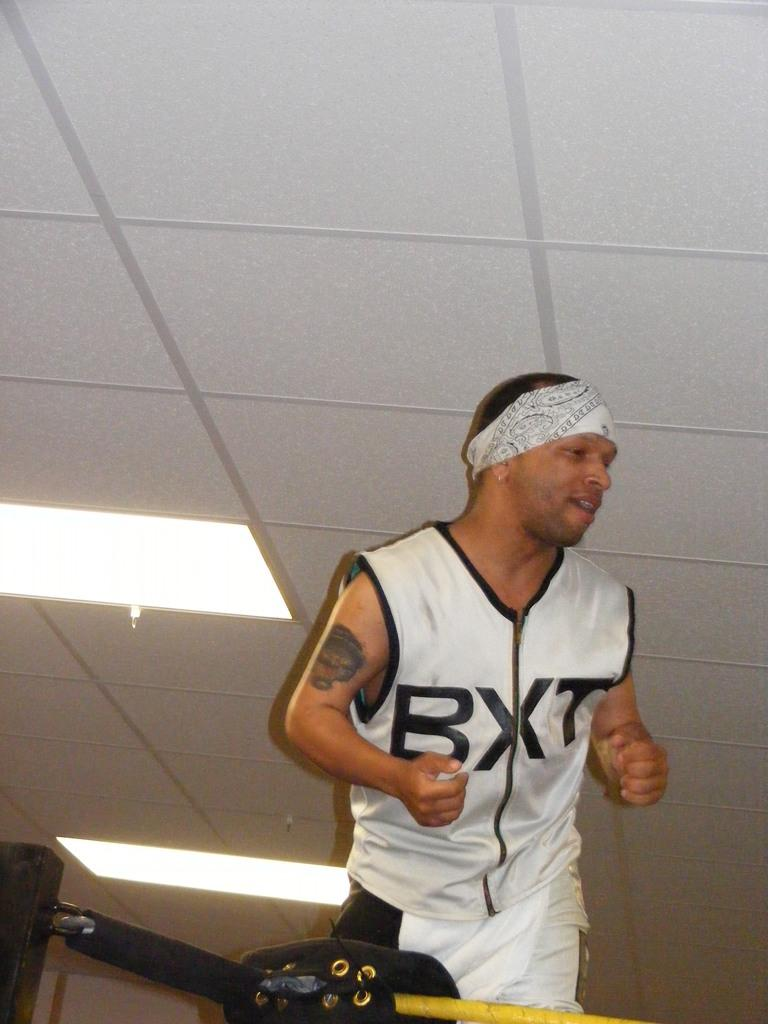<image>
Create a compact narrative representing the image presented. a man smiles while wearing a sleeveless shirt with BXT on it 